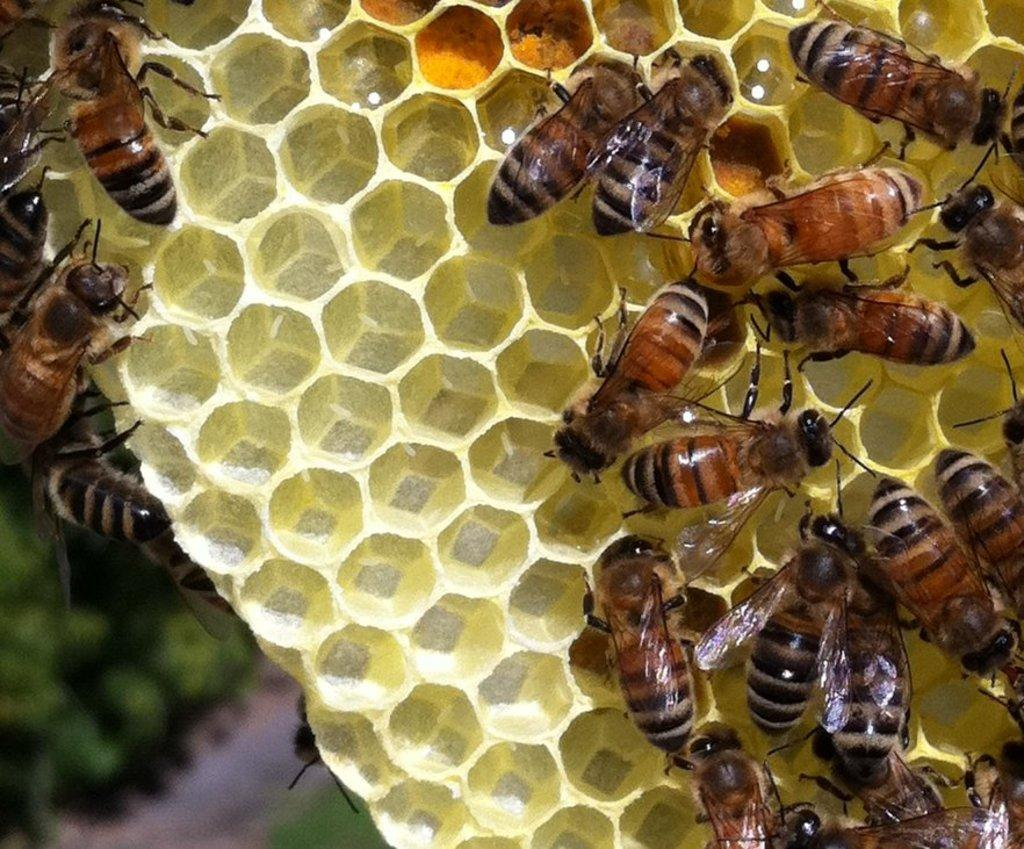What type of insects are present in the image? There are honey bees in the image. Where are the honey bees located? The honey bees are on a hive. Can you describe the background of the image? The background of the image is blurry. How many apples are being pecked by the hen in the image? There are no apples or hens present in the image; it features honey bees on a hive. What type of rhythm is being played by the honey bees in the image? Honey bees do not play any rhythm; they are insects that collect pollen and nectar from flowers. 